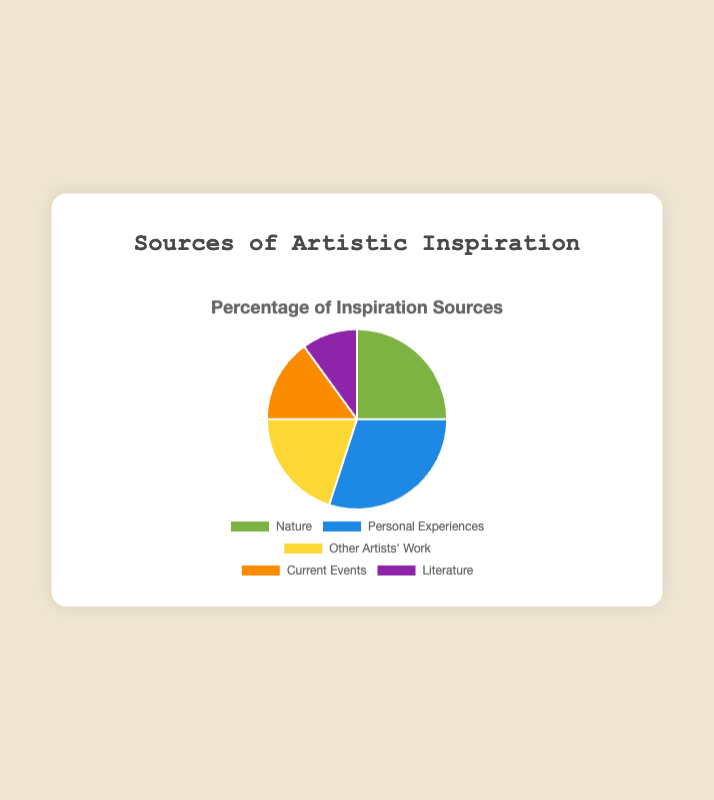Which source contributes the most to artistic inspiration? The source with the highest percentage on the pie chart is the one that contributes the most. Here, "Personal Experiences" has the highest percentage at 30%.
Answer: Personal Experiences Which source of artistic inspiration has the smallest percentage? Look for the smallest segment on the pie chart, which is "Literature" at 10%.
Answer: Literature What is the combined percentage of "Nature" and "Current Events"? Sum the percentages of "Nature" (25%) and "Current Events" (15%). 25 + 15 = 40.
Answer: 40% Which is more influential, "Other Artists' Work" or "Current Events"? Compare the percentages of "Other Artists' Work" (20%) and "Current Events" (15%). "Other Artists' Work" has a higher percentage.
Answer: Other Artists' Work What is the difference between the highest and lowest sources of inspiration? Subtract the smallest percentage ("Literature" at 10%) from the largest percentage ("Personal Experiences" at 30%). 30 - 10 = 20.
Answer: 20% Which source has a purple segment in the pie chart? Identify the segment with the purple color, which represents "Literature".
Answer: Literature Are "Nature" and "Personal Experiences" combined more than 50%? Sum the percentages of "Nature" (25%) and "Personal Experiences" (30%). 25 + 30 = 55, which is more than 50%.
Answer: Yes What percentage of artistic inspiration comes from sources outside of "Nature" and "Personal Experiences"? Subtract the combined percentage of "Nature" (25%) and "Personal Experiences" (30%) from 100%. 100 - (25 + 30) = 45.
Answer: 45% Which two sources have a combined influence of 50%? Look for pairs whose sum equals 50%. "Nature" (25%) and "Other Artists' Work" (20%) together with "Current Events" (15%) equals 55%. The more exact combination is "Nature" (25%) and "Personal Experiences" (30%), because 25 + 30 = 55 which closest to combined percentage 50%.
Answer: Nature and Personal Experiences 